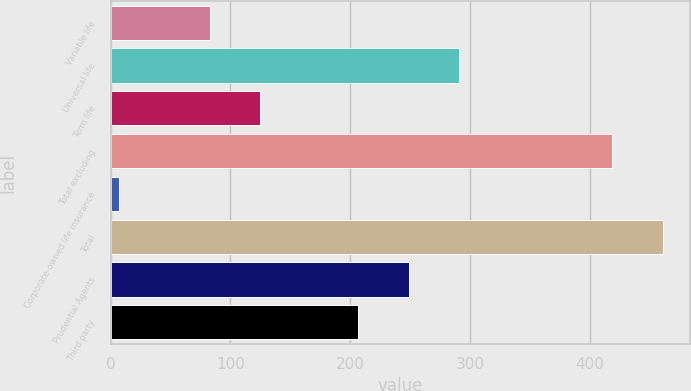Convert chart to OTSL. <chart><loc_0><loc_0><loc_500><loc_500><bar_chart><fcel>Variable life<fcel>Universal life<fcel>Term life<fcel>Total excluding<fcel>Corporate-owned life insurance<fcel>Total<fcel>Prudential Agents<fcel>Third party<nl><fcel>83<fcel>290.8<fcel>124.9<fcel>419<fcel>7<fcel>460.9<fcel>248.9<fcel>207<nl></chart> 